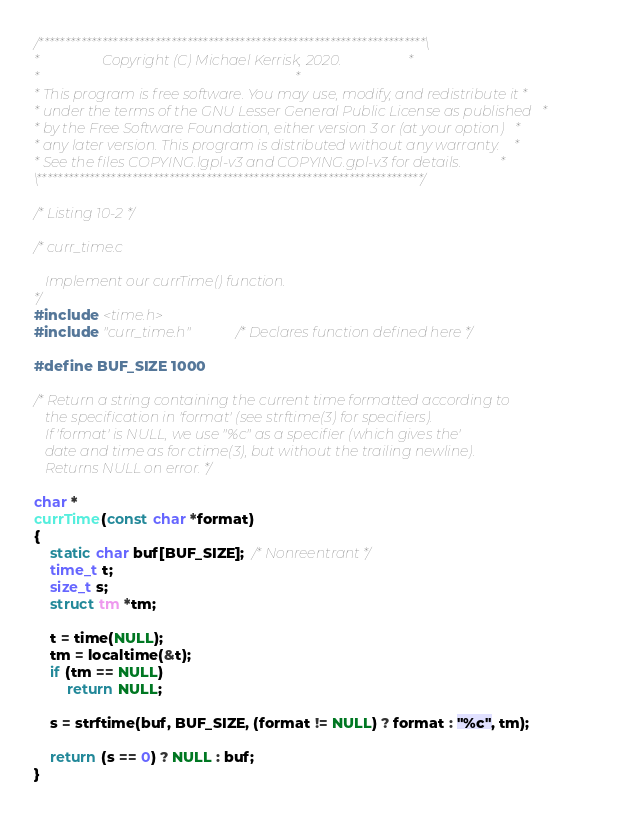<code> <loc_0><loc_0><loc_500><loc_500><_C_>/*************************************************************************\
*                  Copyright (C) Michael Kerrisk, 2020.                   *
*                                                                         *
* This program is free software. You may use, modify, and redistribute it *
* under the terms of the GNU Lesser General Public License as published   *
* by the Free Software Foundation, either version 3 or (at your option)   *
* any later version. This program is distributed without any warranty.    *
* See the files COPYING.lgpl-v3 and COPYING.gpl-v3 for details.           *
\*************************************************************************/

/* Listing 10-2 */

/* curr_time.c

   Implement our currTime() function.
*/
#include <time.h>
#include "curr_time.h"          /* Declares function defined here */

#define BUF_SIZE 1000

/* Return a string containing the current time formatted according to
   the specification in 'format' (see strftime(3) for specifiers).
   If 'format' is NULL, we use "%c" as a specifier (which gives the'
   date and time as for ctime(3), but without the trailing newline).
   Returns NULL on error. */

char *
currTime(const char *format)
{
    static char buf[BUF_SIZE];  /* Nonreentrant */
    time_t t;
    size_t s;
    struct tm *tm;

    t = time(NULL);
    tm = localtime(&t);
    if (tm == NULL)
        return NULL;

    s = strftime(buf, BUF_SIZE, (format != NULL) ? format : "%c", tm);

    return (s == 0) ? NULL : buf;
}
</code> 